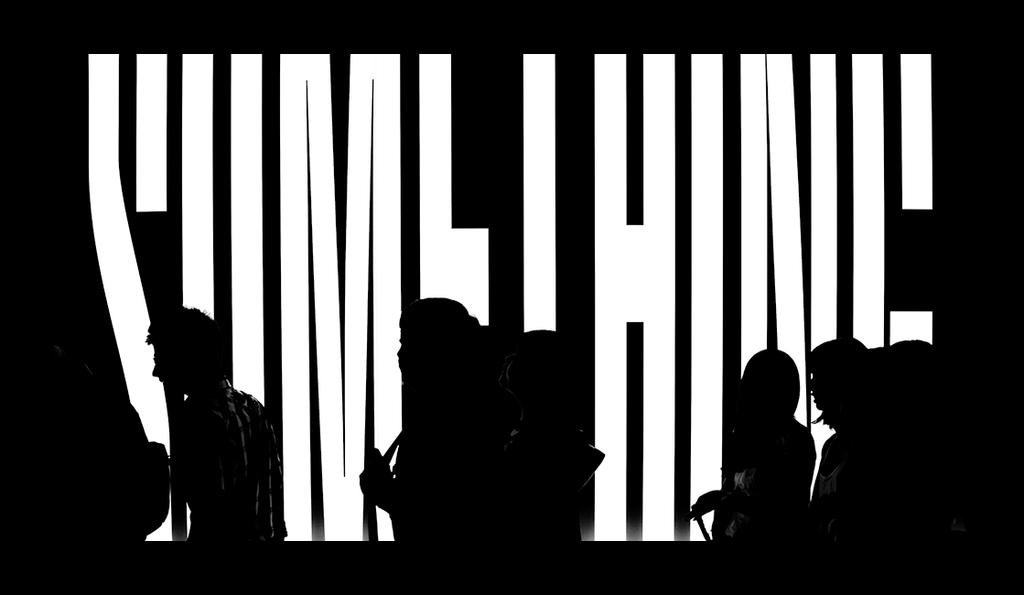How many people are in the image? There is a group of persons in the image. What are the people in the image doing? The group of persons is walking. What color is the screen in the background of the image? There is a black color screen in the background of the image. What can be seen on the screen? There are white color letters on the screen. What type of notebook is the person reading in the image? There is no person reading a notebook in the image; the group of persons is walking. What is the plot of the story being read by the person in the image? There is no person reading a story in the image; the group of persons is walking. 